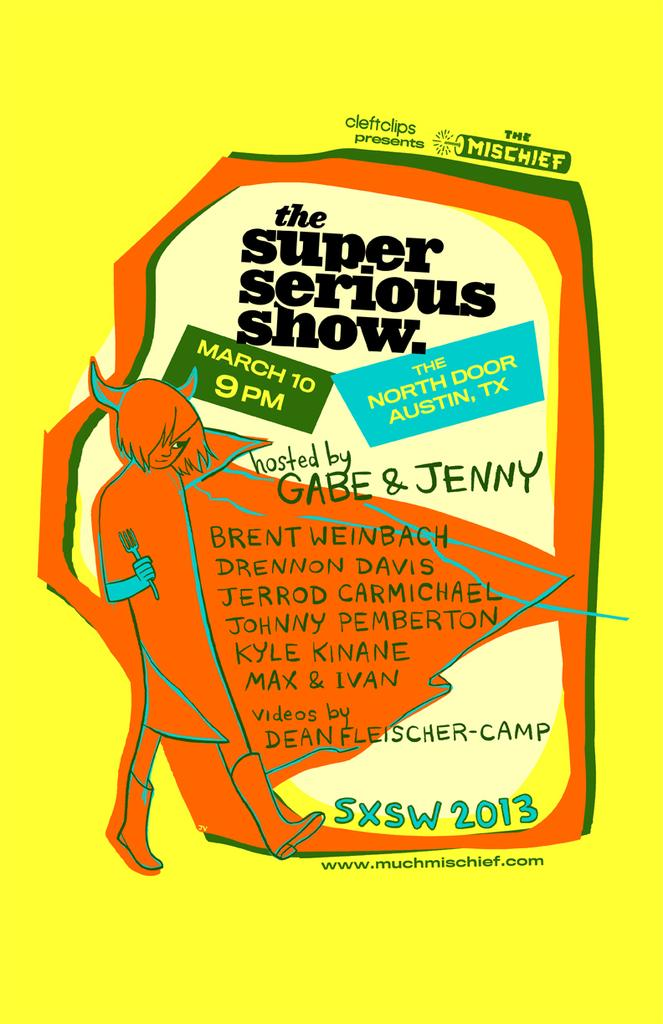Provide a one-sentence caption for the provided image. Gabe and Jenny host the super serious show. 